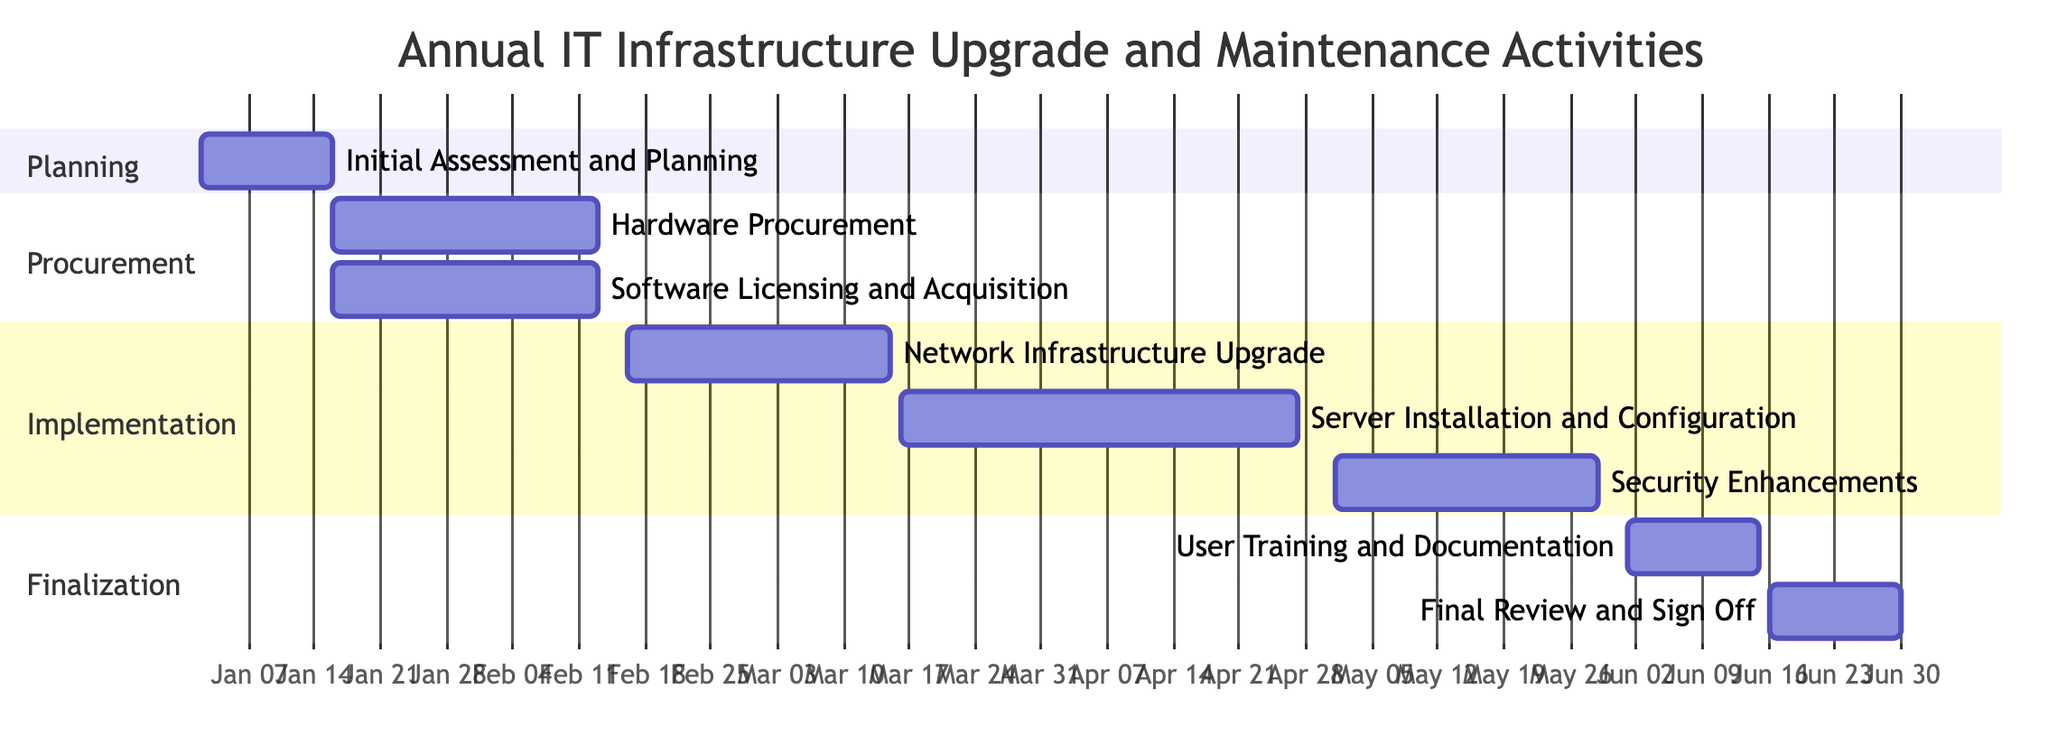What is the total number of tasks in the project? The diagram lists a series of tasks under different sections. Counting the tasks displayed, there are eight distinct tasks mentioned.
Answer: 8 What is the duration of the Hardware Procurement task? The task detail states that the Hardware Procurement task has a duration of four weeks, as indicated in the Gantt chart.
Answer: 4 weeks Which task starts immediately after the Initial Assessment and Planning? The Gantt chart shows that the Hardware Procurement task begins right after the completion of the Initial Assessment and Planning, which concludes on January 15.
Answer: Hardware Procurement What is the ending date of the User Training and Documentation task? Looking at the User Training and Documentation task, it is shown to end on June 15, 2024, based on the provided dates.
Answer: June 15, 2024 How many weeks are allocated for the Server Installation and Configuration task? The chart indicates that the Server Installation and Configuration task spans six weeks from March 16 to April 30.
Answer: 6 weeks Which tasks are scheduled to occur simultaneously? Examining the procurement section, both Hardware Procurement and Software Licensing and Acquisition tasks are scheduled to start on January 16 and run concurrently for four weeks.
Answer: Hardware Procurement and Software Licensing and Acquisition What is the start date of the Security Enhancements task? The Gantt chart clearly states that the Security Enhancements task starts on May 1, 2024.
Answer: May 1, 2024 Which section contains the most tasks? Upon reviewing the Gantt chart, the Implementation section contains three tasks: Network Infrastructure Upgrade, Server Installation and Configuration, and Security Enhancements, which is more than any other section.
Answer: Implementation When is the Final Review and Sign Off task scheduled to start? The diagram shows that the Final Review and Sign Off task starts after the User Training and Documentation task, beginning on June 16, 2024.
Answer: June 16, 2024 